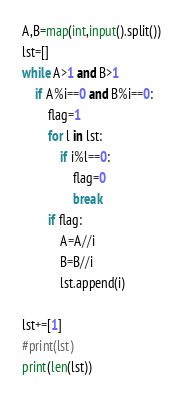<code> <loc_0><loc_0><loc_500><loc_500><_Python_>A,B=map(int,input().split())
lst=[]
while A>1 and B>1
    if A%i==0 and B%i==0:
        flag=1
        for l in lst:
            if i%l==0:
                flag=0
                break
        if flag:
            A=A//i
            B=B//i
            lst.append(i)

lst+=[1]
#print(lst)
print(len(lst))
</code> 